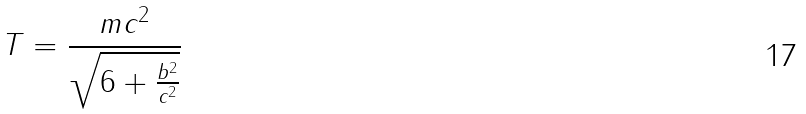<formula> <loc_0><loc_0><loc_500><loc_500>T = \frac { m c ^ { 2 } } { \sqrt { 6 + \frac { b ^ { 2 } } { c ^ { 2 } } } }</formula> 